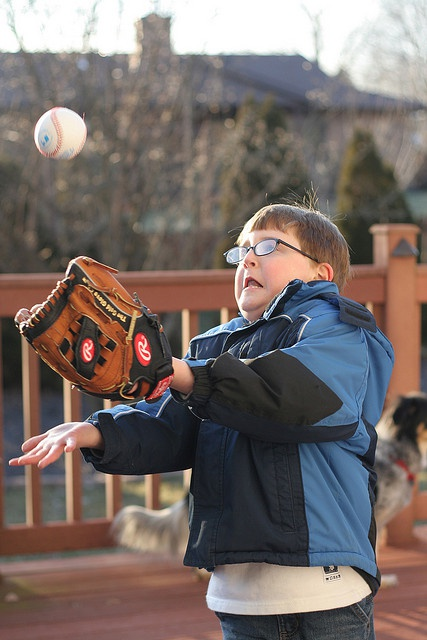Describe the objects in this image and their specific colors. I can see people in white, black, gray, and tan tones, baseball glove in white, black, brown, and maroon tones, dog in white, gray, and black tones, and sports ball in white, ivory, tan, and darkgray tones in this image. 